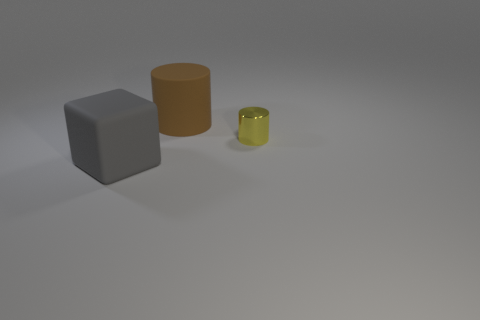Add 1 brown objects. How many objects exist? 4 Subtract all cylinders. How many objects are left? 1 Subtract 0 purple cylinders. How many objects are left? 3 Subtract all yellow shiny cylinders. Subtract all large gray matte objects. How many objects are left? 1 Add 3 big objects. How many big objects are left? 5 Add 1 big blue rubber cylinders. How many big blue rubber cylinders exist? 1 